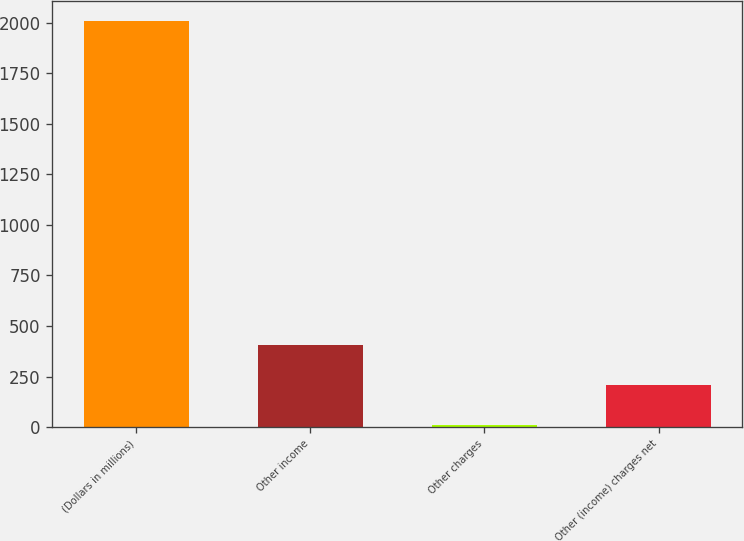<chart> <loc_0><loc_0><loc_500><loc_500><bar_chart><fcel>(Dollars in millions)<fcel>Other income<fcel>Other charges<fcel>Other (income) charges net<nl><fcel>2006<fcel>407.6<fcel>8<fcel>207.8<nl></chart> 